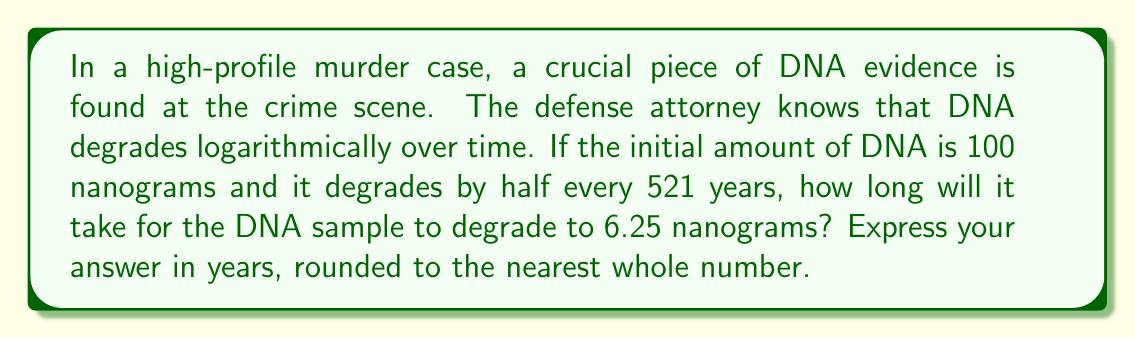Help me with this question. Let's approach this step-by-step:

1) We can model this situation using the exponential decay formula:
   $A(t) = A_0 \cdot (1/2)^{t/h}$
   Where:
   $A(t)$ is the amount after time $t$
   $A_0$ is the initial amount
   $h$ is the half-life

2) We're given:
   $A_0 = 100$ nanograms
   $h = 521$ years
   $A(t) = 6.25$ nanograms

3) Plugging these into our formula:
   $6.25 = 100 \cdot (1/2)^{t/521}$

4) Divide both sides by 100:
   $0.0625 = (1/2)^{t/521}$

5) Take the logarithm (base 2) of both sides:
   $\log_2(0.0625) = t/521$

6) Simplify the left side:
   $-4 = t/521$

7) Multiply both sides by 521:
   $-4 \cdot 521 = t$

8) Solve for $t$:
   $t = 2084$ years

Therefore, it will take approximately 2084 years for the DNA sample to degrade to 6.25 nanograms.
Answer: 2084 years 